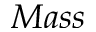<formula> <loc_0><loc_0><loc_500><loc_500>M a s s</formula> 